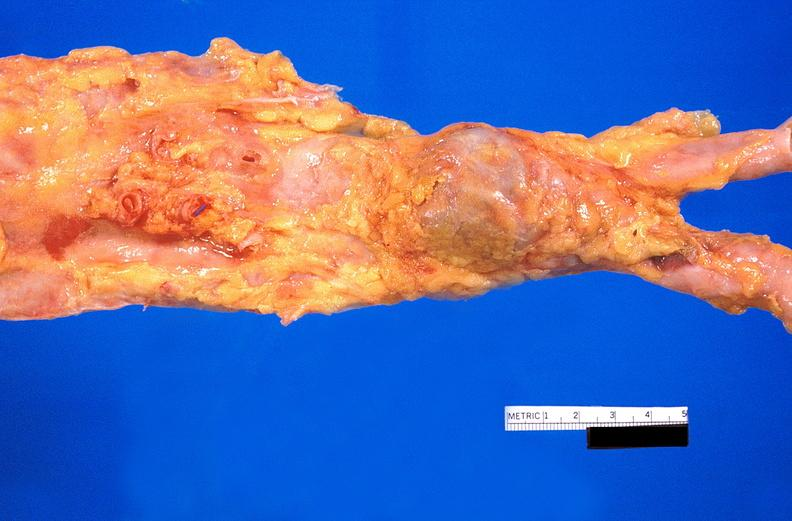what does this image show?
Answer the question using a single word or phrase. Abdominal aorta 